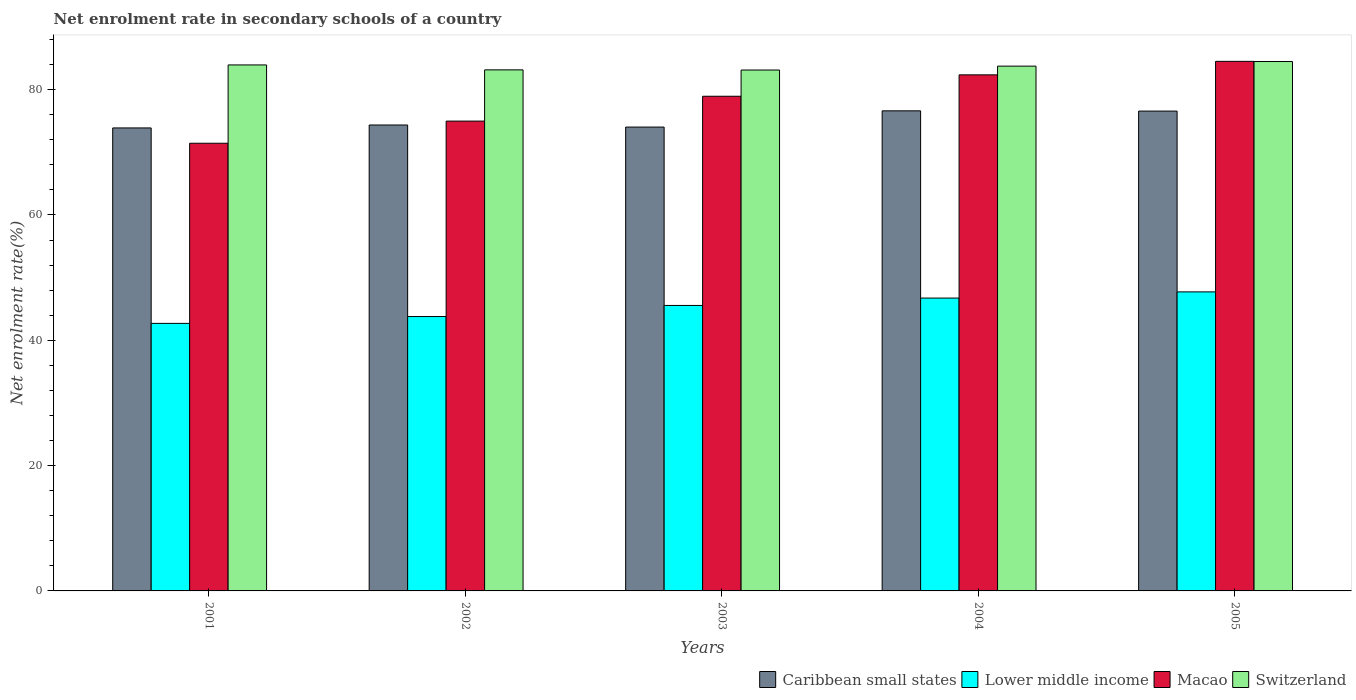How many groups of bars are there?
Provide a succinct answer. 5. Are the number of bars per tick equal to the number of legend labels?
Offer a terse response. Yes. How many bars are there on the 5th tick from the left?
Ensure brevity in your answer.  4. In how many cases, is the number of bars for a given year not equal to the number of legend labels?
Provide a short and direct response. 0. What is the net enrolment rate in secondary schools in Lower middle income in 2003?
Make the answer very short. 45.56. Across all years, what is the maximum net enrolment rate in secondary schools in Macao?
Your answer should be compact. 84.52. Across all years, what is the minimum net enrolment rate in secondary schools in Macao?
Your answer should be very brief. 71.45. In which year was the net enrolment rate in secondary schools in Macao minimum?
Your answer should be very brief. 2001. What is the total net enrolment rate in secondary schools in Macao in the graph?
Make the answer very short. 392.25. What is the difference between the net enrolment rate in secondary schools in Lower middle income in 2002 and that in 2003?
Keep it short and to the point. -1.77. What is the difference between the net enrolment rate in secondary schools in Caribbean small states in 2003 and the net enrolment rate in secondary schools in Switzerland in 2002?
Your answer should be very brief. -9.13. What is the average net enrolment rate in secondary schools in Lower middle income per year?
Ensure brevity in your answer.  45.3. In the year 2005, what is the difference between the net enrolment rate in secondary schools in Lower middle income and net enrolment rate in secondary schools in Caribbean small states?
Provide a succinct answer. -28.85. What is the ratio of the net enrolment rate in secondary schools in Caribbean small states in 2001 to that in 2004?
Offer a terse response. 0.96. Is the net enrolment rate in secondary schools in Lower middle income in 2001 less than that in 2002?
Give a very brief answer. Yes. What is the difference between the highest and the second highest net enrolment rate in secondary schools in Lower middle income?
Keep it short and to the point. 0.99. What is the difference between the highest and the lowest net enrolment rate in secondary schools in Macao?
Make the answer very short. 13.07. What does the 3rd bar from the left in 2004 represents?
Give a very brief answer. Macao. What does the 4th bar from the right in 2005 represents?
Your answer should be very brief. Caribbean small states. How many years are there in the graph?
Offer a very short reply. 5. Are the values on the major ticks of Y-axis written in scientific E-notation?
Ensure brevity in your answer.  No. Where does the legend appear in the graph?
Give a very brief answer. Bottom right. What is the title of the graph?
Keep it short and to the point. Net enrolment rate in secondary schools of a country. Does "Cambodia" appear as one of the legend labels in the graph?
Make the answer very short. No. What is the label or title of the X-axis?
Keep it short and to the point. Years. What is the label or title of the Y-axis?
Make the answer very short. Net enrolment rate(%). What is the Net enrolment rate(%) in Caribbean small states in 2001?
Provide a succinct answer. 73.89. What is the Net enrolment rate(%) in Lower middle income in 2001?
Keep it short and to the point. 42.7. What is the Net enrolment rate(%) in Macao in 2001?
Give a very brief answer. 71.45. What is the Net enrolment rate(%) in Switzerland in 2001?
Your answer should be very brief. 83.95. What is the Net enrolment rate(%) in Caribbean small states in 2002?
Your response must be concise. 74.36. What is the Net enrolment rate(%) in Lower middle income in 2002?
Offer a very short reply. 43.79. What is the Net enrolment rate(%) of Macao in 2002?
Ensure brevity in your answer.  74.98. What is the Net enrolment rate(%) of Switzerland in 2002?
Your response must be concise. 83.16. What is the Net enrolment rate(%) of Caribbean small states in 2003?
Ensure brevity in your answer.  74.03. What is the Net enrolment rate(%) in Lower middle income in 2003?
Give a very brief answer. 45.56. What is the Net enrolment rate(%) in Macao in 2003?
Provide a short and direct response. 78.95. What is the Net enrolment rate(%) in Switzerland in 2003?
Offer a very short reply. 83.13. What is the Net enrolment rate(%) of Caribbean small states in 2004?
Make the answer very short. 76.62. What is the Net enrolment rate(%) in Lower middle income in 2004?
Offer a terse response. 46.74. What is the Net enrolment rate(%) of Macao in 2004?
Keep it short and to the point. 82.36. What is the Net enrolment rate(%) in Switzerland in 2004?
Give a very brief answer. 83.75. What is the Net enrolment rate(%) of Caribbean small states in 2005?
Ensure brevity in your answer.  76.58. What is the Net enrolment rate(%) in Lower middle income in 2005?
Keep it short and to the point. 47.73. What is the Net enrolment rate(%) in Macao in 2005?
Your response must be concise. 84.52. What is the Net enrolment rate(%) of Switzerland in 2005?
Make the answer very short. 84.49. Across all years, what is the maximum Net enrolment rate(%) in Caribbean small states?
Give a very brief answer. 76.62. Across all years, what is the maximum Net enrolment rate(%) in Lower middle income?
Make the answer very short. 47.73. Across all years, what is the maximum Net enrolment rate(%) in Macao?
Offer a very short reply. 84.52. Across all years, what is the maximum Net enrolment rate(%) of Switzerland?
Offer a terse response. 84.49. Across all years, what is the minimum Net enrolment rate(%) of Caribbean small states?
Offer a terse response. 73.89. Across all years, what is the minimum Net enrolment rate(%) in Lower middle income?
Make the answer very short. 42.7. Across all years, what is the minimum Net enrolment rate(%) in Macao?
Provide a succinct answer. 71.45. Across all years, what is the minimum Net enrolment rate(%) of Switzerland?
Your answer should be very brief. 83.13. What is the total Net enrolment rate(%) of Caribbean small states in the graph?
Provide a short and direct response. 375.48. What is the total Net enrolment rate(%) in Lower middle income in the graph?
Your answer should be compact. 226.51. What is the total Net enrolment rate(%) of Macao in the graph?
Provide a succinct answer. 392.25. What is the total Net enrolment rate(%) of Switzerland in the graph?
Make the answer very short. 418.48. What is the difference between the Net enrolment rate(%) of Caribbean small states in 2001 and that in 2002?
Make the answer very short. -0.47. What is the difference between the Net enrolment rate(%) in Lower middle income in 2001 and that in 2002?
Provide a short and direct response. -1.09. What is the difference between the Net enrolment rate(%) of Macao in 2001 and that in 2002?
Ensure brevity in your answer.  -3.54. What is the difference between the Net enrolment rate(%) in Switzerland in 2001 and that in 2002?
Your answer should be very brief. 0.79. What is the difference between the Net enrolment rate(%) of Caribbean small states in 2001 and that in 2003?
Give a very brief answer. -0.14. What is the difference between the Net enrolment rate(%) in Lower middle income in 2001 and that in 2003?
Offer a terse response. -2.86. What is the difference between the Net enrolment rate(%) in Macao in 2001 and that in 2003?
Keep it short and to the point. -7.5. What is the difference between the Net enrolment rate(%) in Switzerland in 2001 and that in 2003?
Provide a succinct answer. 0.81. What is the difference between the Net enrolment rate(%) of Caribbean small states in 2001 and that in 2004?
Make the answer very short. -2.73. What is the difference between the Net enrolment rate(%) in Lower middle income in 2001 and that in 2004?
Provide a succinct answer. -4.04. What is the difference between the Net enrolment rate(%) in Macao in 2001 and that in 2004?
Your answer should be compact. -10.92. What is the difference between the Net enrolment rate(%) of Switzerland in 2001 and that in 2004?
Give a very brief answer. 0.19. What is the difference between the Net enrolment rate(%) in Caribbean small states in 2001 and that in 2005?
Your answer should be very brief. -2.69. What is the difference between the Net enrolment rate(%) in Lower middle income in 2001 and that in 2005?
Your response must be concise. -5.03. What is the difference between the Net enrolment rate(%) of Macao in 2001 and that in 2005?
Your answer should be compact. -13.07. What is the difference between the Net enrolment rate(%) of Switzerland in 2001 and that in 2005?
Your response must be concise. -0.54. What is the difference between the Net enrolment rate(%) of Caribbean small states in 2002 and that in 2003?
Keep it short and to the point. 0.33. What is the difference between the Net enrolment rate(%) of Lower middle income in 2002 and that in 2003?
Your answer should be compact. -1.77. What is the difference between the Net enrolment rate(%) of Macao in 2002 and that in 2003?
Make the answer very short. -3.96. What is the difference between the Net enrolment rate(%) of Switzerland in 2002 and that in 2003?
Your answer should be compact. 0.02. What is the difference between the Net enrolment rate(%) in Caribbean small states in 2002 and that in 2004?
Make the answer very short. -2.26. What is the difference between the Net enrolment rate(%) in Lower middle income in 2002 and that in 2004?
Give a very brief answer. -2.95. What is the difference between the Net enrolment rate(%) in Macao in 2002 and that in 2004?
Provide a succinct answer. -7.38. What is the difference between the Net enrolment rate(%) of Switzerland in 2002 and that in 2004?
Offer a terse response. -0.59. What is the difference between the Net enrolment rate(%) in Caribbean small states in 2002 and that in 2005?
Your answer should be compact. -2.22. What is the difference between the Net enrolment rate(%) of Lower middle income in 2002 and that in 2005?
Provide a short and direct response. -3.94. What is the difference between the Net enrolment rate(%) in Macao in 2002 and that in 2005?
Your answer should be compact. -9.53. What is the difference between the Net enrolment rate(%) of Switzerland in 2002 and that in 2005?
Provide a short and direct response. -1.33. What is the difference between the Net enrolment rate(%) in Caribbean small states in 2003 and that in 2004?
Offer a very short reply. -2.59. What is the difference between the Net enrolment rate(%) of Lower middle income in 2003 and that in 2004?
Offer a terse response. -1.18. What is the difference between the Net enrolment rate(%) in Macao in 2003 and that in 2004?
Keep it short and to the point. -3.42. What is the difference between the Net enrolment rate(%) of Switzerland in 2003 and that in 2004?
Offer a terse response. -0.62. What is the difference between the Net enrolment rate(%) of Caribbean small states in 2003 and that in 2005?
Provide a succinct answer. -2.55. What is the difference between the Net enrolment rate(%) in Lower middle income in 2003 and that in 2005?
Offer a terse response. -2.17. What is the difference between the Net enrolment rate(%) in Macao in 2003 and that in 2005?
Your answer should be compact. -5.57. What is the difference between the Net enrolment rate(%) in Switzerland in 2003 and that in 2005?
Offer a very short reply. -1.36. What is the difference between the Net enrolment rate(%) of Caribbean small states in 2004 and that in 2005?
Provide a succinct answer. 0.04. What is the difference between the Net enrolment rate(%) in Lower middle income in 2004 and that in 2005?
Your answer should be very brief. -0.99. What is the difference between the Net enrolment rate(%) of Macao in 2004 and that in 2005?
Provide a short and direct response. -2.15. What is the difference between the Net enrolment rate(%) of Switzerland in 2004 and that in 2005?
Provide a succinct answer. -0.74. What is the difference between the Net enrolment rate(%) in Caribbean small states in 2001 and the Net enrolment rate(%) in Lower middle income in 2002?
Provide a succinct answer. 30.1. What is the difference between the Net enrolment rate(%) of Caribbean small states in 2001 and the Net enrolment rate(%) of Macao in 2002?
Ensure brevity in your answer.  -1.09. What is the difference between the Net enrolment rate(%) in Caribbean small states in 2001 and the Net enrolment rate(%) in Switzerland in 2002?
Give a very brief answer. -9.27. What is the difference between the Net enrolment rate(%) in Lower middle income in 2001 and the Net enrolment rate(%) in Macao in 2002?
Keep it short and to the point. -32.28. What is the difference between the Net enrolment rate(%) in Lower middle income in 2001 and the Net enrolment rate(%) in Switzerland in 2002?
Offer a terse response. -40.46. What is the difference between the Net enrolment rate(%) in Macao in 2001 and the Net enrolment rate(%) in Switzerland in 2002?
Your response must be concise. -11.71. What is the difference between the Net enrolment rate(%) of Caribbean small states in 2001 and the Net enrolment rate(%) of Lower middle income in 2003?
Provide a short and direct response. 28.33. What is the difference between the Net enrolment rate(%) of Caribbean small states in 2001 and the Net enrolment rate(%) of Macao in 2003?
Ensure brevity in your answer.  -5.05. What is the difference between the Net enrolment rate(%) of Caribbean small states in 2001 and the Net enrolment rate(%) of Switzerland in 2003?
Give a very brief answer. -9.24. What is the difference between the Net enrolment rate(%) in Lower middle income in 2001 and the Net enrolment rate(%) in Macao in 2003?
Offer a very short reply. -36.25. What is the difference between the Net enrolment rate(%) in Lower middle income in 2001 and the Net enrolment rate(%) in Switzerland in 2003?
Keep it short and to the point. -40.44. What is the difference between the Net enrolment rate(%) of Macao in 2001 and the Net enrolment rate(%) of Switzerland in 2003?
Offer a very short reply. -11.69. What is the difference between the Net enrolment rate(%) of Caribbean small states in 2001 and the Net enrolment rate(%) of Lower middle income in 2004?
Make the answer very short. 27.15. What is the difference between the Net enrolment rate(%) in Caribbean small states in 2001 and the Net enrolment rate(%) in Macao in 2004?
Offer a terse response. -8.47. What is the difference between the Net enrolment rate(%) in Caribbean small states in 2001 and the Net enrolment rate(%) in Switzerland in 2004?
Provide a succinct answer. -9.86. What is the difference between the Net enrolment rate(%) of Lower middle income in 2001 and the Net enrolment rate(%) of Macao in 2004?
Offer a very short reply. -39.66. What is the difference between the Net enrolment rate(%) in Lower middle income in 2001 and the Net enrolment rate(%) in Switzerland in 2004?
Make the answer very short. -41.06. What is the difference between the Net enrolment rate(%) of Macao in 2001 and the Net enrolment rate(%) of Switzerland in 2004?
Your answer should be very brief. -12.31. What is the difference between the Net enrolment rate(%) in Caribbean small states in 2001 and the Net enrolment rate(%) in Lower middle income in 2005?
Provide a short and direct response. 26.17. What is the difference between the Net enrolment rate(%) in Caribbean small states in 2001 and the Net enrolment rate(%) in Macao in 2005?
Offer a very short reply. -10.63. What is the difference between the Net enrolment rate(%) of Caribbean small states in 2001 and the Net enrolment rate(%) of Switzerland in 2005?
Make the answer very short. -10.6. What is the difference between the Net enrolment rate(%) of Lower middle income in 2001 and the Net enrolment rate(%) of Macao in 2005?
Your response must be concise. -41.82. What is the difference between the Net enrolment rate(%) in Lower middle income in 2001 and the Net enrolment rate(%) in Switzerland in 2005?
Your answer should be very brief. -41.79. What is the difference between the Net enrolment rate(%) of Macao in 2001 and the Net enrolment rate(%) of Switzerland in 2005?
Provide a short and direct response. -13.04. What is the difference between the Net enrolment rate(%) of Caribbean small states in 2002 and the Net enrolment rate(%) of Lower middle income in 2003?
Give a very brief answer. 28.8. What is the difference between the Net enrolment rate(%) in Caribbean small states in 2002 and the Net enrolment rate(%) in Macao in 2003?
Make the answer very short. -4.59. What is the difference between the Net enrolment rate(%) in Caribbean small states in 2002 and the Net enrolment rate(%) in Switzerland in 2003?
Your answer should be compact. -8.78. What is the difference between the Net enrolment rate(%) of Lower middle income in 2002 and the Net enrolment rate(%) of Macao in 2003?
Give a very brief answer. -35.16. What is the difference between the Net enrolment rate(%) of Lower middle income in 2002 and the Net enrolment rate(%) of Switzerland in 2003?
Offer a terse response. -39.34. What is the difference between the Net enrolment rate(%) in Macao in 2002 and the Net enrolment rate(%) in Switzerland in 2003?
Give a very brief answer. -8.15. What is the difference between the Net enrolment rate(%) in Caribbean small states in 2002 and the Net enrolment rate(%) in Lower middle income in 2004?
Make the answer very short. 27.62. What is the difference between the Net enrolment rate(%) of Caribbean small states in 2002 and the Net enrolment rate(%) of Macao in 2004?
Give a very brief answer. -8. What is the difference between the Net enrolment rate(%) in Caribbean small states in 2002 and the Net enrolment rate(%) in Switzerland in 2004?
Provide a succinct answer. -9.39. What is the difference between the Net enrolment rate(%) in Lower middle income in 2002 and the Net enrolment rate(%) in Macao in 2004?
Give a very brief answer. -38.57. What is the difference between the Net enrolment rate(%) of Lower middle income in 2002 and the Net enrolment rate(%) of Switzerland in 2004?
Your response must be concise. -39.96. What is the difference between the Net enrolment rate(%) of Macao in 2002 and the Net enrolment rate(%) of Switzerland in 2004?
Provide a succinct answer. -8.77. What is the difference between the Net enrolment rate(%) in Caribbean small states in 2002 and the Net enrolment rate(%) in Lower middle income in 2005?
Give a very brief answer. 26.63. What is the difference between the Net enrolment rate(%) of Caribbean small states in 2002 and the Net enrolment rate(%) of Macao in 2005?
Your answer should be compact. -10.16. What is the difference between the Net enrolment rate(%) in Caribbean small states in 2002 and the Net enrolment rate(%) in Switzerland in 2005?
Give a very brief answer. -10.13. What is the difference between the Net enrolment rate(%) in Lower middle income in 2002 and the Net enrolment rate(%) in Macao in 2005?
Offer a terse response. -40.73. What is the difference between the Net enrolment rate(%) of Lower middle income in 2002 and the Net enrolment rate(%) of Switzerland in 2005?
Offer a terse response. -40.7. What is the difference between the Net enrolment rate(%) of Macao in 2002 and the Net enrolment rate(%) of Switzerland in 2005?
Give a very brief answer. -9.51. What is the difference between the Net enrolment rate(%) in Caribbean small states in 2003 and the Net enrolment rate(%) in Lower middle income in 2004?
Provide a short and direct response. 27.29. What is the difference between the Net enrolment rate(%) of Caribbean small states in 2003 and the Net enrolment rate(%) of Macao in 2004?
Provide a short and direct response. -8.33. What is the difference between the Net enrolment rate(%) of Caribbean small states in 2003 and the Net enrolment rate(%) of Switzerland in 2004?
Your answer should be very brief. -9.72. What is the difference between the Net enrolment rate(%) in Lower middle income in 2003 and the Net enrolment rate(%) in Macao in 2004?
Your response must be concise. -36.8. What is the difference between the Net enrolment rate(%) of Lower middle income in 2003 and the Net enrolment rate(%) of Switzerland in 2004?
Offer a very short reply. -38.19. What is the difference between the Net enrolment rate(%) of Macao in 2003 and the Net enrolment rate(%) of Switzerland in 2004?
Your response must be concise. -4.81. What is the difference between the Net enrolment rate(%) in Caribbean small states in 2003 and the Net enrolment rate(%) in Lower middle income in 2005?
Provide a short and direct response. 26.3. What is the difference between the Net enrolment rate(%) of Caribbean small states in 2003 and the Net enrolment rate(%) of Macao in 2005?
Give a very brief answer. -10.49. What is the difference between the Net enrolment rate(%) in Caribbean small states in 2003 and the Net enrolment rate(%) in Switzerland in 2005?
Offer a very short reply. -10.46. What is the difference between the Net enrolment rate(%) of Lower middle income in 2003 and the Net enrolment rate(%) of Macao in 2005?
Ensure brevity in your answer.  -38.96. What is the difference between the Net enrolment rate(%) of Lower middle income in 2003 and the Net enrolment rate(%) of Switzerland in 2005?
Offer a terse response. -38.93. What is the difference between the Net enrolment rate(%) of Macao in 2003 and the Net enrolment rate(%) of Switzerland in 2005?
Provide a short and direct response. -5.54. What is the difference between the Net enrolment rate(%) in Caribbean small states in 2004 and the Net enrolment rate(%) in Lower middle income in 2005?
Make the answer very short. 28.89. What is the difference between the Net enrolment rate(%) of Caribbean small states in 2004 and the Net enrolment rate(%) of Macao in 2005?
Ensure brevity in your answer.  -7.9. What is the difference between the Net enrolment rate(%) of Caribbean small states in 2004 and the Net enrolment rate(%) of Switzerland in 2005?
Give a very brief answer. -7.87. What is the difference between the Net enrolment rate(%) in Lower middle income in 2004 and the Net enrolment rate(%) in Macao in 2005?
Offer a very short reply. -37.78. What is the difference between the Net enrolment rate(%) of Lower middle income in 2004 and the Net enrolment rate(%) of Switzerland in 2005?
Your answer should be very brief. -37.75. What is the difference between the Net enrolment rate(%) of Macao in 2004 and the Net enrolment rate(%) of Switzerland in 2005?
Your answer should be very brief. -2.13. What is the average Net enrolment rate(%) in Caribbean small states per year?
Provide a short and direct response. 75.1. What is the average Net enrolment rate(%) in Lower middle income per year?
Make the answer very short. 45.3. What is the average Net enrolment rate(%) of Macao per year?
Your response must be concise. 78.45. What is the average Net enrolment rate(%) in Switzerland per year?
Offer a very short reply. 83.7. In the year 2001, what is the difference between the Net enrolment rate(%) of Caribbean small states and Net enrolment rate(%) of Lower middle income?
Your answer should be compact. 31.19. In the year 2001, what is the difference between the Net enrolment rate(%) in Caribbean small states and Net enrolment rate(%) in Macao?
Make the answer very short. 2.44. In the year 2001, what is the difference between the Net enrolment rate(%) of Caribbean small states and Net enrolment rate(%) of Switzerland?
Keep it short and to the point. -10.06. In the year 2001, what is the difference between the Net enrolment rate(%) in Lower middle income and Net enrolment rate(%) in Macao?
Ensure brevity in your answer.  -28.75. In the year 2001, what is the difference between the Net enrolment rate(%) in Lower middle income and Net enrolment rate(%) in Switzerland?
Provide a short and direct response. -41.25. In the year 2001, what is the difference between the Net enrolment rate(%) of Macao and Net enrolment rate(%) of Switzerland?
Keep it short and to the point. -12.5. In the year 2002, what is the difference between the Net enrolment rate(%) in Caribbean small states and Net enrolment rate(%) in Lower middle income?
Make the answer very short. 30.57. In the year 2002, what is the difference between the Net enrolment rate(%) of Caribbean small states and Net enrolment rate(%) of Macao?
Give a very brief answer. -0.62. In the year 2002, what is the difference between the Net enrolment rate(%) of Caribbean small states and Net enrolment rate(%) of Switzerland?
Your answer should be compact. -8.8. In the year 2002, what is the difference between the Net enrolment rate(%) of Lower middle income and Net enrolment rate(%) of Macao?
Give a very brief answer. -31.19. In the year 2002, what is the difference between the Net enrolment rate(%) of Lower middle income and Net enrolment rate(%) of Switzerland?
Provide a succinct answer. -39.37. In the year 2002, what is the difference between the Net enrolment rate(%) in Macao and Net enrolment rate(%) in Switzerland?
Your answer should be compact. -8.18. In the year 2003, what is the difference between the Net enrolment rate(%) of Caribbean small states and Net enrolment rate(%) of Lower middle income?
Provide a short and direct response. 28.47. In the year 2003, what is the difference between the Net enrolment rate(%) of Caribbean small states and Net enrolment rate(%) of Macao?
Keep it short and to the point. -4.92. In the year 2003, what is the difference between the Net enrolment rate(%) in Caribbean small states and Net enrolment rate(%) in Switzerland?
Give a very brief answer. -9.11. In the year 2003, what is the difference between the Net enrolment rate(%) of Lower middle income and Net enrolment rate(%) of Macao?
Keep it short and to the point. -33.39. In the year 2003, what is the difference between the Net enrolment rate(%) of Lower middle income and Net enrolment rate(%) of Switzerland?
Make the answer very short. -37.57. In the year 2003, what is the difference between the Net enrolment rate(%) of Macao and Net enrolment rate(%) of Switzerland?
Your response must be concise. -4.19. In the year 2004, what is the difference between the Net enrolment rate(%) in Caribbean small states and Net enrolment rate(%) in Lower middle income?
Ensure brevity in your answer.  29.88. In the year 2004, what is the difference between the Net enrolment rate(%) in Caribbean small states and Net enrolment rate(%) in Macao?
Keep it short and to the point. -5.74. In the year 2004, what is the difference between the Net enrolment rate(%) of Caribbean small states and Net enrolment rate(%) of Switzerland?
Give a very brief answer. -7.13. In the year 2004, what is the difference between the Net enrolment rate(%) in Lower middle income and Net enrolment rate(%) in Macao?
Keep it short and to the point. -35.62. In the year 2004, what is the difference between the Net enrolment rate(%) in Lower middle income and Net enrolment rate(%) in Switzerland?
Offer a very short reply. -37.02. In the year 2004, what is the difference between the Net enrolment rate(%) in Macao and Net enrolment rate(%) in Switzerland?
Provide a short and direct response. -1.39. In the year 2005, what is the difference between the Net enrolment rate(%) of Caribbean small states and Net enrolment rate(%) of Lower middle income?
Keep it short and to the point. 28.85. In the year 2005, what is the difference between the Net enrolment rate(%) in Caribbean small states and Net enrolment rate(%) in Macao?
Make the answer very short. -7.94. In the year 2005, what is the difference between the Net enrolment rate(%) in Caribbean small states and Net enrolment rate(%) in Switzerland?
Keep it short and to the point. -7.91. In the year 2005, what is the difference between the Net enrolment rate(%) of Lower middle income and Net enrolment rate(%) of Macao?
Provide a succinct answer. -36.79. In the year 2005, what is the difference between the Net enrolment rate(%) in Lower middle income and Net enrolment rate(%) in Switzerland?
Provide a succinct answer. -36.76. In the year 2005, what is the difference between the Net enrolment rate(%) of Macao and Net enrolment rate(%) of Switzerland?
Offer a very short reply. 0.03. What is the ratio of the Net enrolment rate(%) in Caribbean small states in 2001 to that in 2002?
Your answer should be very brief. 0.99. What is the ratio of the Net enrolment rate(%) in Lower middle income in 2001 to that in 2002?
Give a very brief answer. 0.98. What is the ratio of the Net enrolment rate(%) in Macao in 2001 to that in 2002?
Provide a short and direct response. 0.95. What is the ratio of the Net enrolment rate(%) of Switzerland in 2001 to that in 2002?
Provide a short and direct response. 1.01. What is the ratio of the Net enrolment rate(%) in Lower middle income in 2001 to that in 2003?
Make the answer very short. 0.94. What is the ratio of the Net enrolment rate(%) of Macao in 2001 to that in 2003?
Your answer should be compact. 0.91. What is the ratio of the Net enrolment rate(%) in Switzerland in 2001 to that in 2003?
Your answer should be compact. 1.01. What is the ratio of the Net enrolment rate(%) of Caribbean small states in 2001 to that in 2004?
Your response must be concise. 0.96. What is the ratio of the Net enrolment rate(%) of Lower middle income in 2001 to that in 2004?
Offer a terse response. 0.91. What is the ratio of the Net enrolment rate(%) in Macao in 2001 to that in 2004?
Give a very brief answer. 0.87. What is the ratio of the Net enrolment rate(%) of Caribbean small states in 2001 to that in 2005?
Offer a terse response. 0.96. What is the ratio of the Net enrolment rate(%) in Lower middle income in 2001 to that in 2005?
Give a very brief answer. 0.89. What is the ratio of the Net enrolment rate(%) of Macao in 2001 to that in 2005?
Your answer should be compact. 0.85. What is the ratio of the Net enrolment rate(%) in Switzerland in 2001 to that in 2005?
Keep it short and to the point. 0.99. What is the ratio of the Net enrolment rate(%) of Caribbean small states in 2002 to that in 2003?
Offer a very short reply. 1. What is the ratio of the Net enrolment rate(%) in Lower middle income in 2002 to that in 2003?
Ensure brevity in your answer.  0.96. What is the ratio of the Net enrolment rate(%) in Macao in 2002 to that in 2003?
Your answer should be very brief. 0.95. What is the ratio of the Net enrolment rate(%) in Caribbean small states in 2002 to that in 2004?
Provide a succinct answer. 0.97. What is the ratio of the Net enrolment rate(%) in Lower middle income in 2002 to that in 2004?
Offer a very short reply. 0.94. What is the ratio of the Net enrolment rate(%) in Macao in 2002 to that in 2004?
Keep it short and to the point. 0.91. What is the ratio of the Net enrolment rate(%) of Caribbean small states in 2002 to that in 2005?
Offer a terse response. 0.97. What is the ratio of the Net enrolment rate(%) of Lower middle income in 2002 to that in 2005?
Offer a very short reply. 0.92. What is the ratio of the Net enrolment rate(%) in Macao in 2002 to that in 2005?
Offer a very short reply. 0.89. What is the ratio of the Net enrolment rate(%) in Switzerland in 2002 to that in 2005?
Your response must be concise. 0.98. What is the ratio of the Net enrolment rate(%) of Caribbean small states in 2003 to that in 2004?
Your response must be concise. 0.97. What is the ratio of the Net enrolment rate(%) of Lower middle income in 2003 to that in 2004?
Ensure brevity in your answer.  0.97. What is the ratio of the Net enrolment rate(%) in Macao in 2003 to that in 2004?
Give a very brief answer. 0.96. What is the ratio of the Net enrolment rate(%) in Switzerland in 2003 to that in 2004?
Offer a terse response. 0.99. What is the ratio of the Net enrolment rate(%) in Caribbean small states in 2003 to that in 2005?
Offer a terse response. 0.97. What is the ratio of the Net enrolment rate(%) in Lower middle income in 2003 to that in 2005?
Make the answer very short. 0.95. What is the ratio of the Net enrolment rate(%) of Macao in 2003 to that in 2005?
Your answer should be very brief. 0.93. What is the ratio of the Net enrolment rate(%) of Lower middle income in 2004 to that in 2005?
Provide a short and direct response. 0.98. What is the ratio of the Net enrolment rate(%) in Macao in 2004 to that in 2005?
Your response must be concise. 0.97. What is the ratio of the Net enrolment rate(%) of Switzerland in 2004 to that in 2005?
Ensure brevity in your answer.  0.99. What is the difference between the highest and the second highest Net enrolment rate(%) of Caribbean small states?
Provide a succinct answer. 0.04. What is the difference between the highest and the second highest Net enrolment rate(%) in Lower middle income?
Ensure brevity in your answer.  0.99. What is the difference between the highest and the second highest Net enrolment rate(%) of Macao?
Give a very brief answer. 2.15. What is the difference between the highest and the second highest Net enrolment rate(%) of Switzerland?
Provide a short and direct response. 0.54. What is the difference between the highest and the lowest Net enrolment rate(%) of Caribbean small states?
Your answer should be compact. 2.73. What is the difference between the highest and the lowest Net enrolment rate(%) in Lower middle income?
Your response must be concise. 5.03. What is the difference between the highest and the lowest Net enrolment rate(%) of Macao?
Your answer should be very brief. 13.07. What is the difference between the highest and the lowest Net enrolment rate(%) of Switzerland?
Provide a succinct answer. 1.36. 